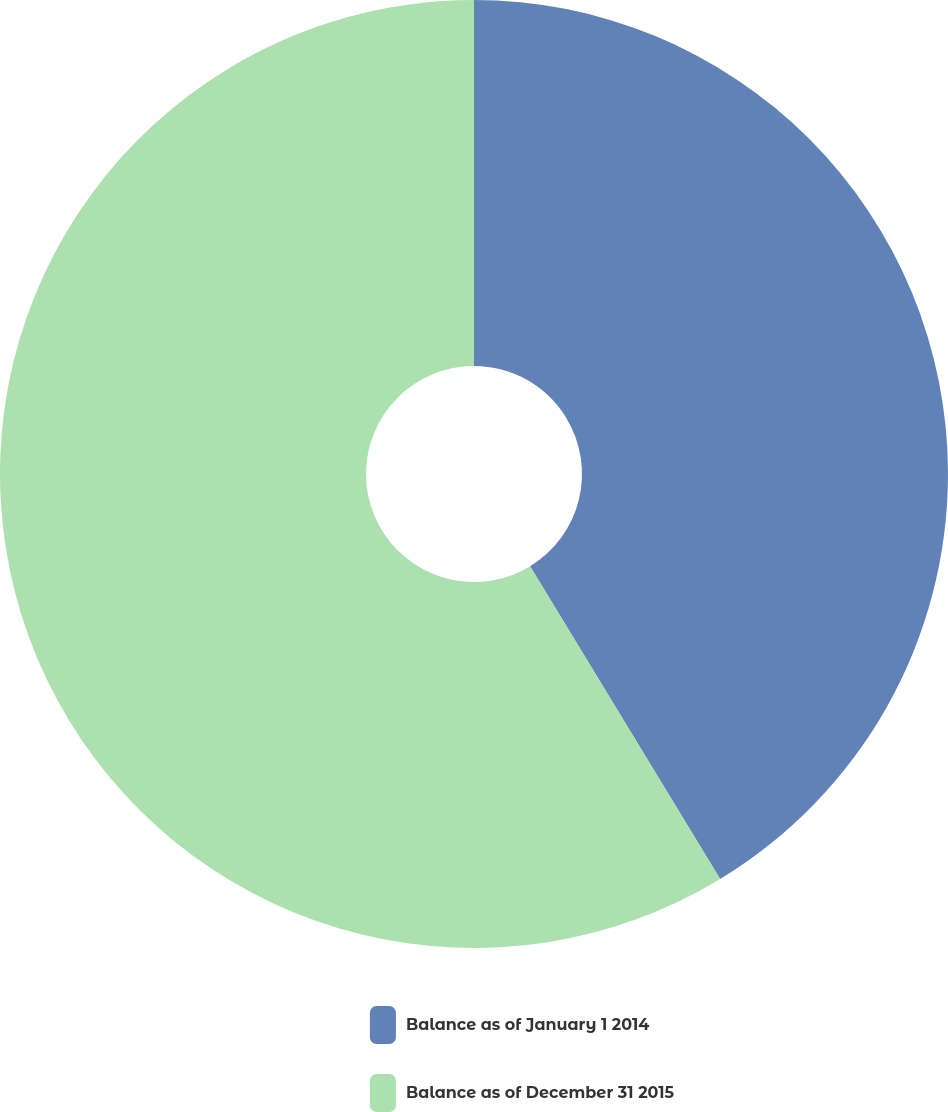Convert chart. <chart><loc_0><loc_0><loc_500><loc_500><pie_chart><fcel>Balance as of January 1 2014<fcel>Balance as of December 31 2015<nl><fcel>41.31%<fcel>58.69%<nl></chart> 